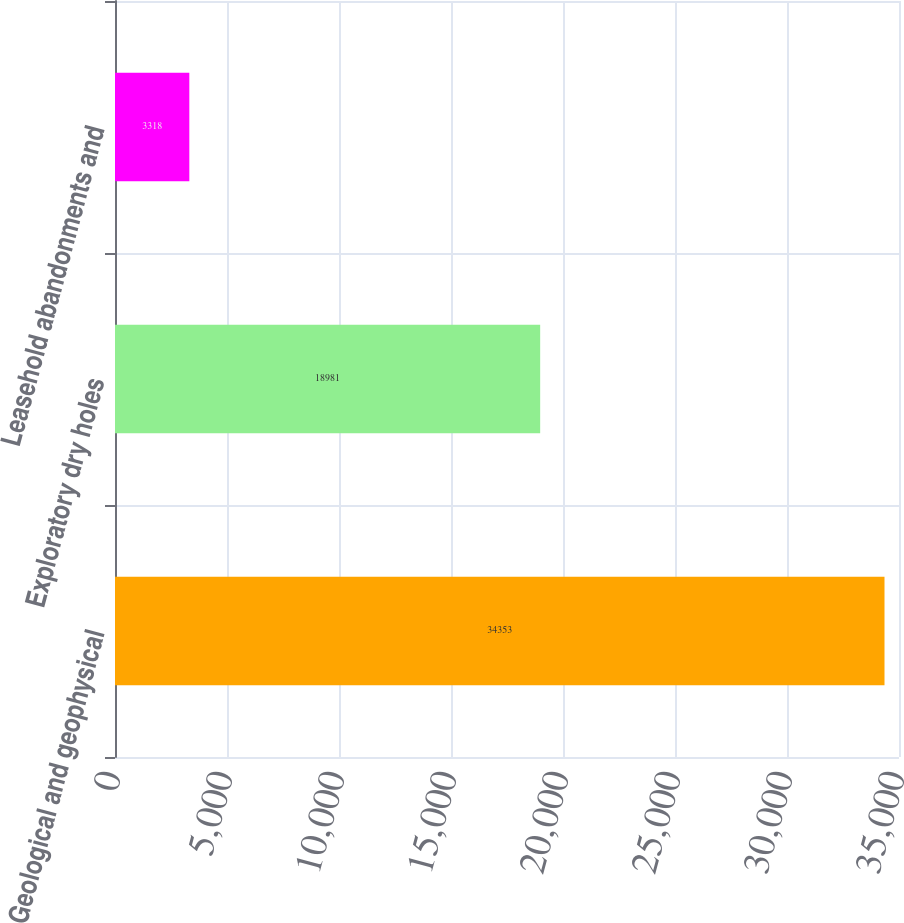Convert chart. <chart><loc_0><loc_0><loc_500><loc_500><bar_chart><fcel>Geological and geophysical<fcel>Exploratory dry holes<fcel>Leasehold abandonments and<nl><fcel>34353<fcel>18981<fcel>3318<nl></chart> 